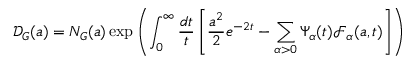Convert formula to latex. <formula><loc_0><loc_0><loc_500><loc_500>\mathcal { D } _ { G } ( a ) = N _ { G } ( a ) \exp \left ( \int _ { 0 } ^ { \infty } \frac { d t } { t } \left [ \frac { a ^ { 2 } } { 2 } e ^ { - 2 t } - \sum _ { \alpha > 0 } \Psi _ { \alpha } ( t ) \mathcal { F } _ { \alpha } ( a , t ) \right ] \right )</formula> 